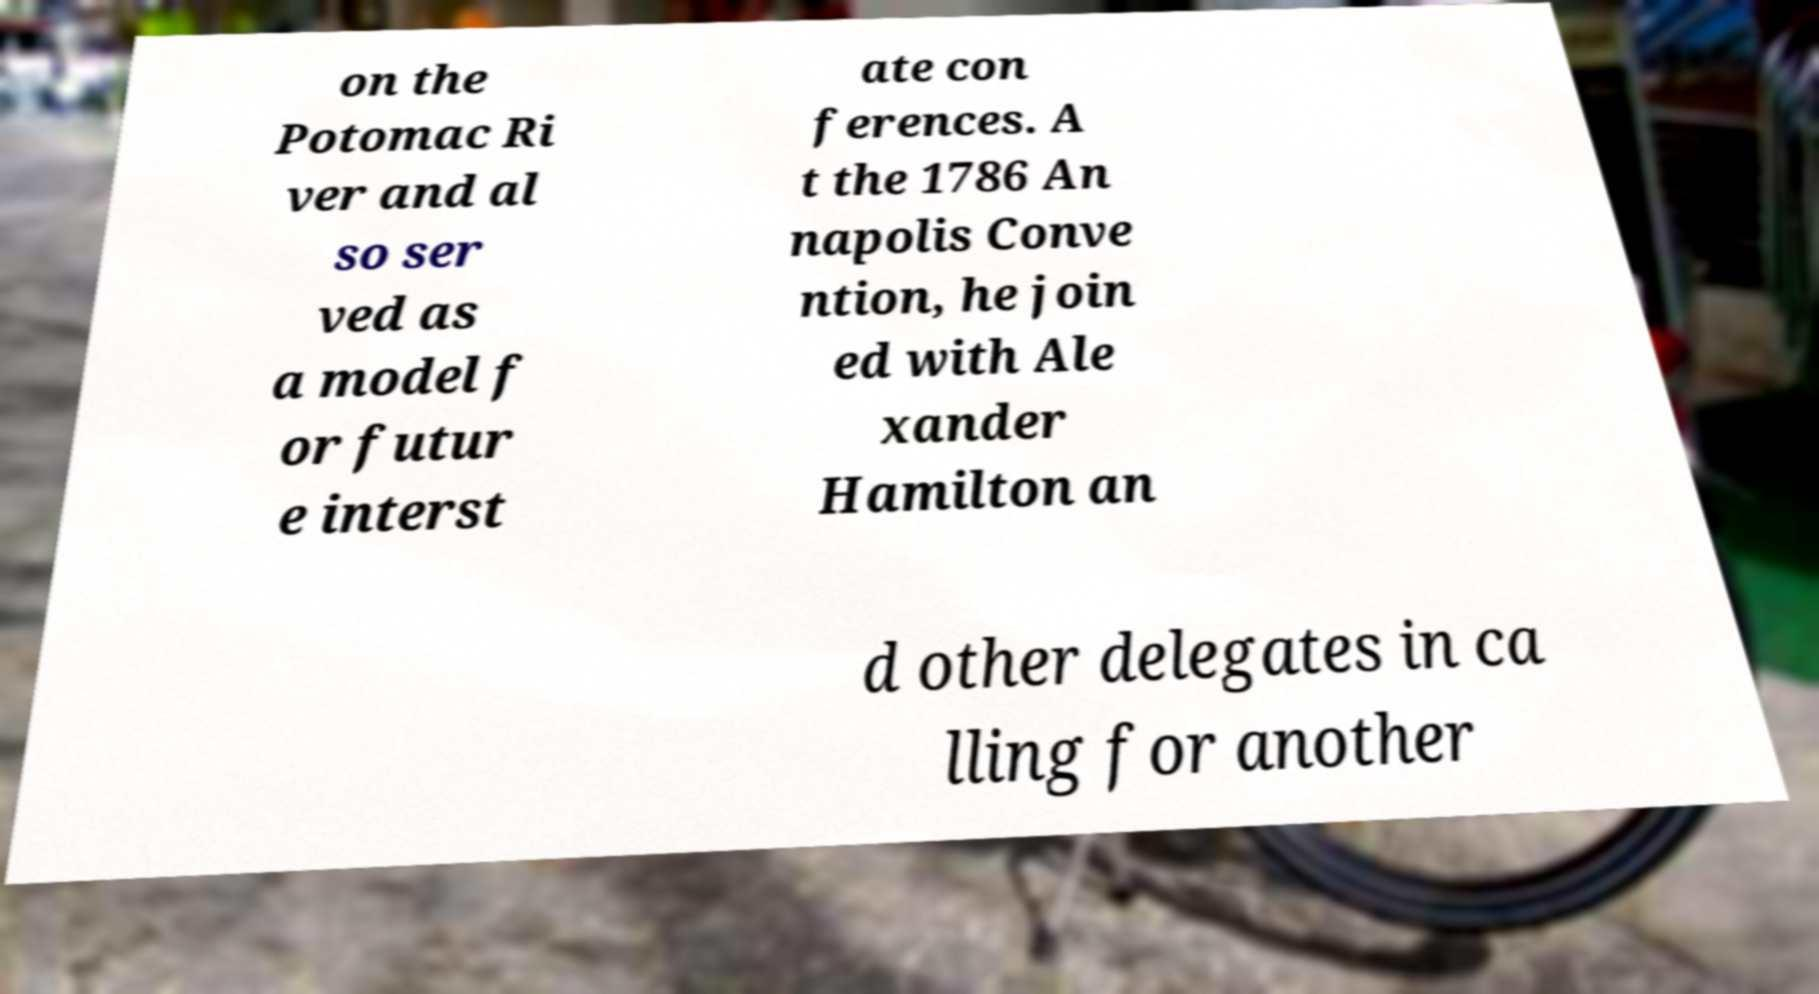Could you assist in decoding the text presented in this image and type it out clearly? on the Potomac Ri ver and al so ser ved as a model f or futur e interst ate con ferences. A t the 1786 An napolis Conve ntion, he join ed with Ale xander Hamilton an d other delegates in ca lling for another 